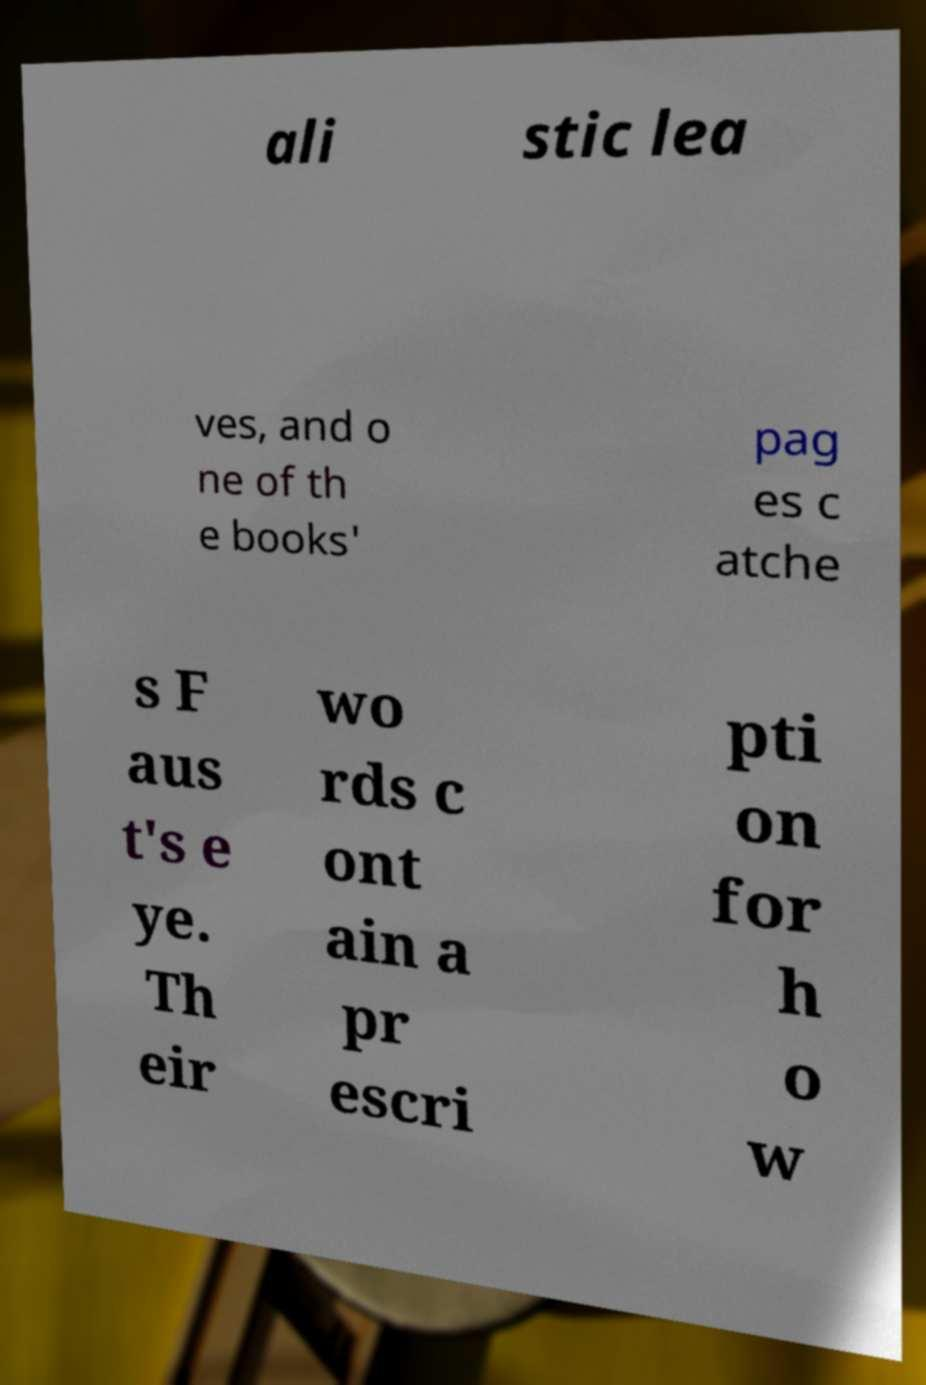I need the written content from this picture converted into text. Can you do that? ali stic lea ves, and o ne of th e books' pag es c atche s F aus t's e ye. Th eir wo rds c ont ain a pr escri pti on for h o w 